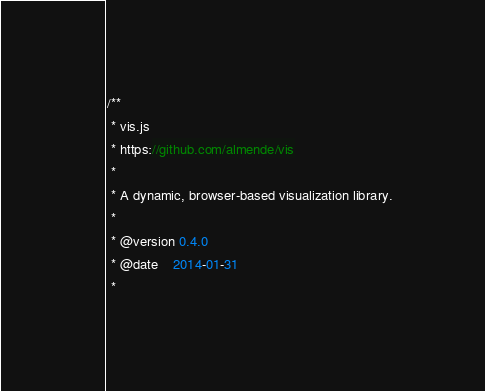<code> <loc_0><loc_0><loc_500><loc_500><_JavaScript_>/**
 * vis.js
 * https://github.com/almende/vis
 *
 * A dynamic, browser-based visualization library.
 *
 * @version 0.4.0
 * @date    2014-01-31
 *</code> 